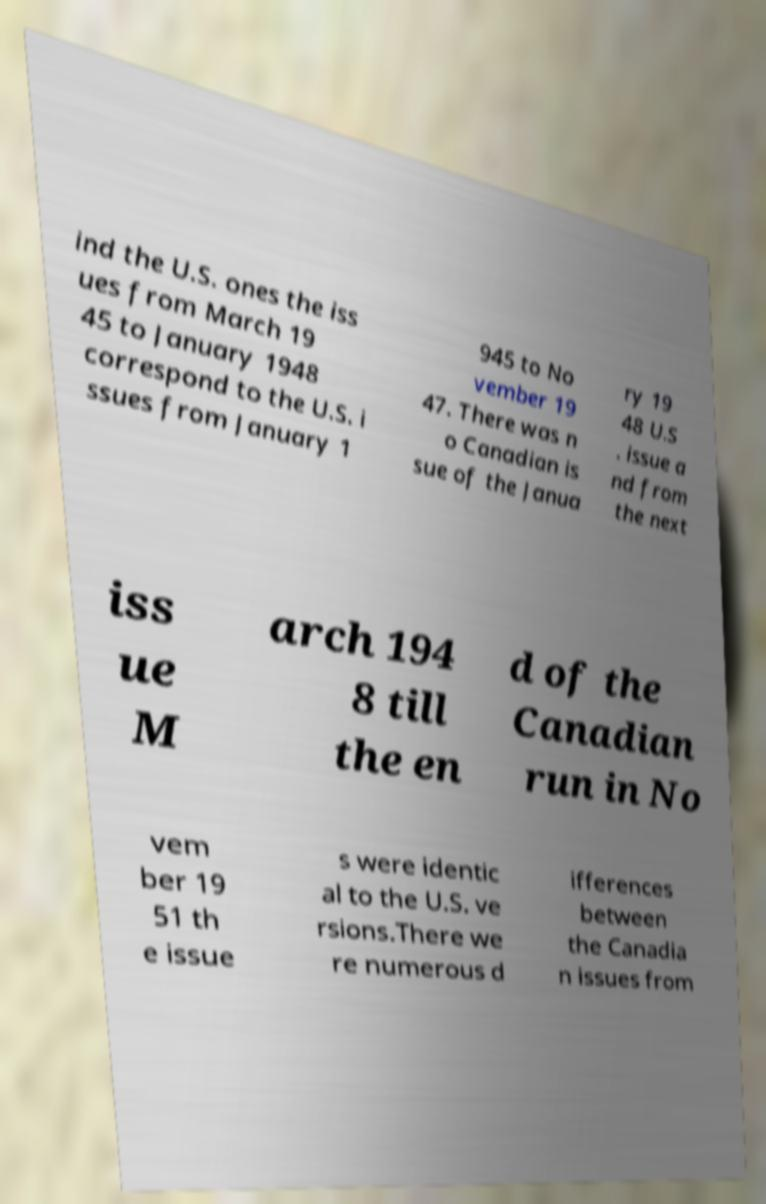There's text embedded in this image that I need extracted. Can you transcribe it verbatim? ind the U.S. ones the iss ues from March 19 45 to January 1948 correspond to the U.S. i ssues from January 1 945 to No vember 19 47. There was n o Canadian is sue of the Janua ry 19 48 U.S . issue a nd from the next iss ue M arch 194 8 till the en d of the Canadian run in No vem ber 19 51 th e issue s were identic al to the U.S. ve rsions.There we re numerous d ifferences between the Canadia n issues from 